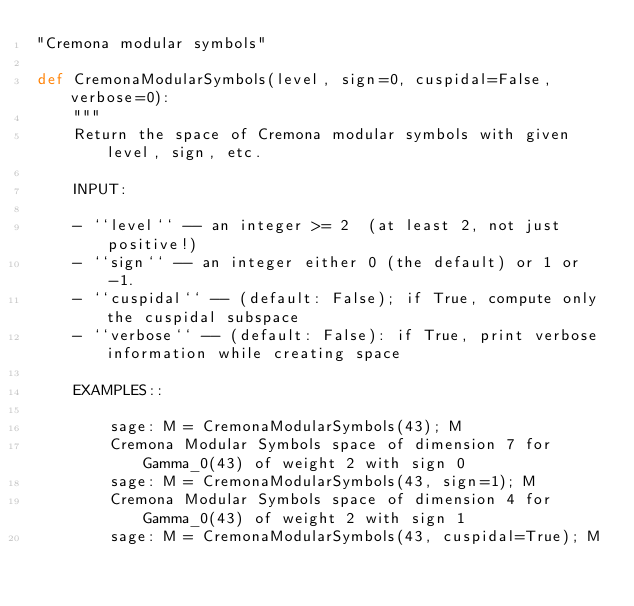Convert code to text. <code><loc_0><loc_0><loc_500><loc_500><_Python_>"Cremona modular symbols"

def CremonaModularSymbols(level, sign=0, cuspidal=False, verbose=0):
    """
    Return the space of Cremona modular symbols with given level, sign, etc.

    INPUT:

    - ``level`` -- an integer >= 2  (at least 2, not just positive!)
    - ``sign`` -- an integer either 0 (the default) or 1 or -1.
    - ``cuspidal`` -- (default: False); if True, compute only the cuspidal subspace
    - ``verbose`` -- (default: False): if True, print verbose information while creating space

    EXAMPLES::

        sage: M = CremonaModularSymbols(43); M
        Cremona Modular Symbols space of dimension 7 for Gamma_0(43) of weight 2 with sign 0
        sage: M = CremonaModularSymbols(43, sign=1); M
        Cremona Modular Symbols space of dimension 4 for Gamma_0(43) of weight 2 with sign 1
        sage: M = CremonaModularSymbols(43, cuspidal=True); M</code> 